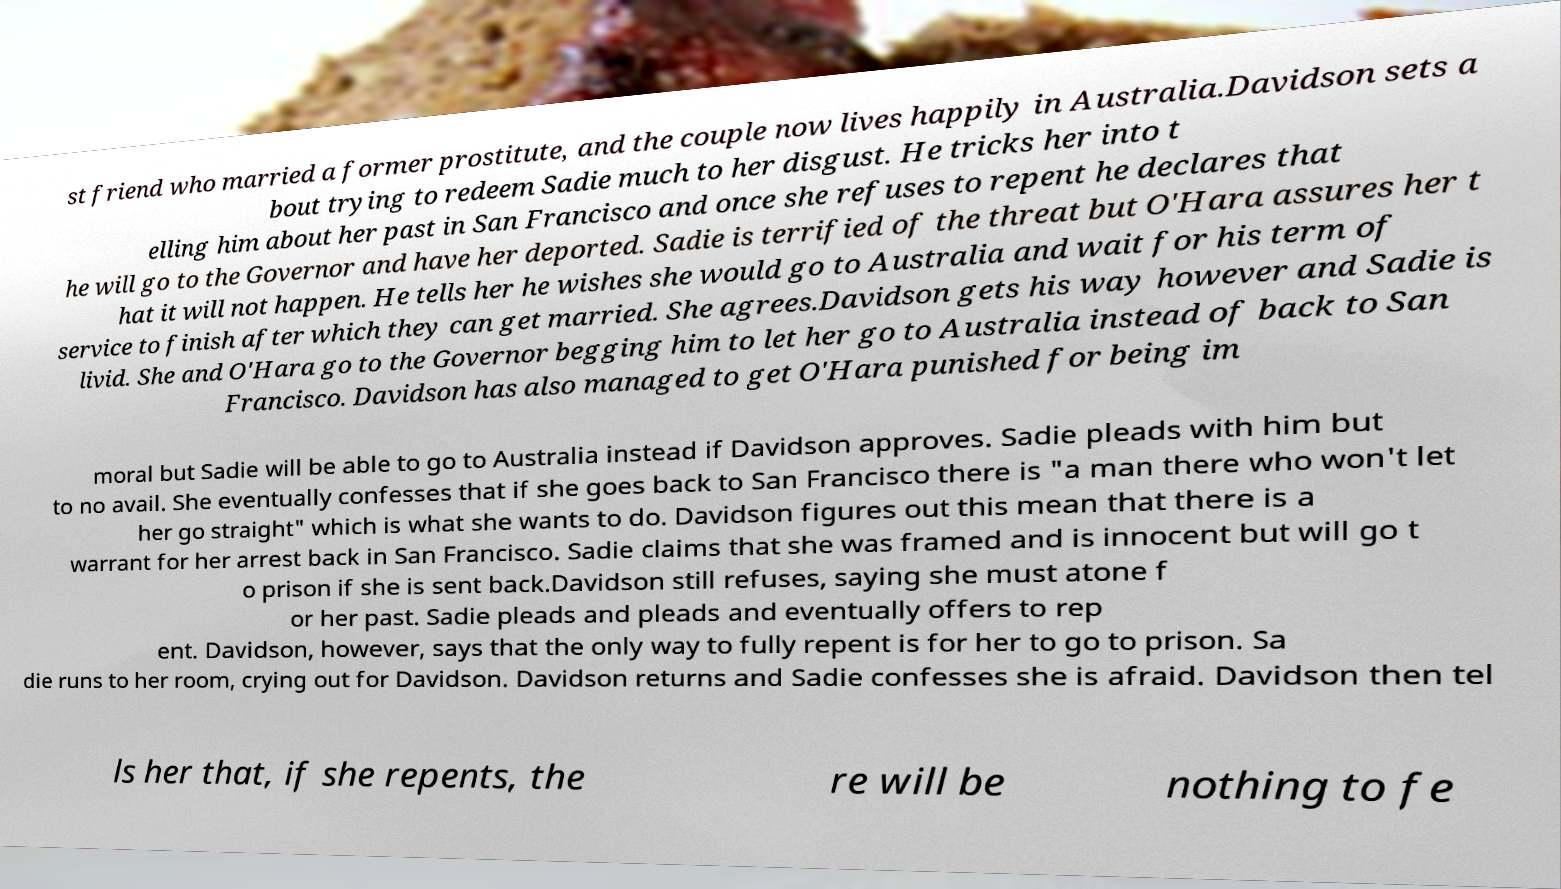Please read and relay the text visible in this image. What does it say? st friend who married a former prostitute, and the couple now lives happily in Australia.Davidson sets a bout trying to redeem Sadie much to her disgust. He tricks her into t elling him about her past in San Francisco and once she refuses to repent he declares that he will go to the Governor and have her deported. Sadie is terrified of the threat but O'Hara assures her t hat it will not happen. He tells her he wishes she would go to Australia and wait for his term of service to finish after which they can get married. She agrees.Davidson gets his way however and Sadie is livid. She and O'Hara go to the Governor begging him to let her go to Australia instead of back to San Francisco. Davidson has also managed to get O'Hara punished for being im moral but Sadie will be able to go to Australia instead if Davidson approves. Sadie pleads with him but to no avail. She eventually confesses that if she goes back to San Francisco there is "a man there who won't let her go straight" which is what she wants to do. Davidson figures out this mean that there is a warrant for her arrest back in San Francisco. Sadie claims that she was framed and is innocent but will go t o prison if she is sent back.Davidson still refuses, saying she must atone f or her past. Sadie pleads and pleads and eventually offers to rep ent. Davidson, however, says that the only way to fully repent is for her to go to prison. Sa die runs to her room, crying out for Davidson. Davidson returns and Sadie confesses she is afraid. Davidson then tel ls her that, if she repents, the re will be nothing to fe 